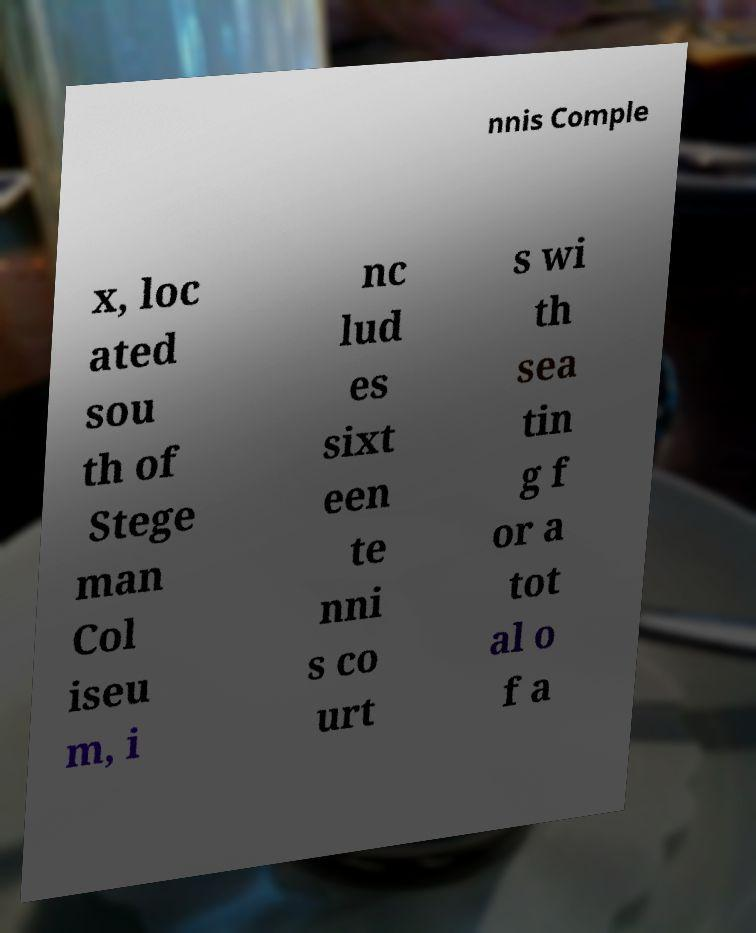Please identify and transcribe the text found in this image. nnis Comple x, loc ated sou th of Stege man Col iseu m, i nc lud es sixt een te nni s co urt s wi th sea tin g f or a tot al o f a 